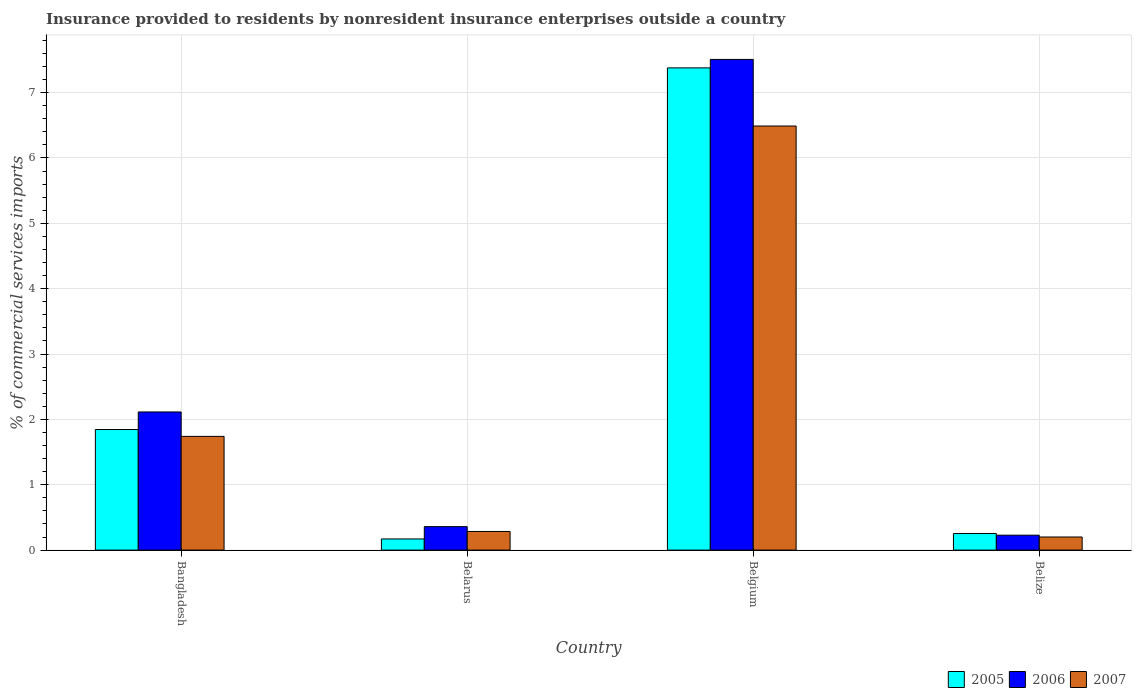How many different coloured bars are there?
Your answer should be very brief. 3. How many groups of bars are there?
Keep it short and to the point. 4. How many bars are there on the 3rd tick from the left?
Give a very brief answer. 3. How many bars are there on the 1st tick from the right?
Make the answer very short. 3. What is the Insurance provided to residents in 2007 in Belgium?
Give a very brief answer. 6.49. Across all countries, what is the maximum Insurance provided to residents in 2006?
Your response must be concise. 7.51. Across all countries, what is the minimum Insurance provided to residents in 2006?
Your answer should be compact. 0.23. In which country was the Insurance provided to residents in 2007 minimum?
Make the answer very short. Belize. What is the total Insurance provided to residents in 2005 in the graph?
Keep it short and to the point. 9.65. What is the difference between the Insurance provided to residents in 2005 in Bangladesh and that in Belarus?
Ensure brevity in your answer.  1.67. What is the difference between the Insurance provided to residents in 2006 in Belgium and the Insurance provided to residents in 2005 in Belarus?
Keep it short and to the point. 7.34. What is the average Insurance provided to residents in 2005 per country?
Keep it short and to the point. 2.41. What is the difference between the Insurance provided to residents of/in 2005 and Insurance provided to residents of/in 2007 in Belarus?
Provide a short and direct response. -0.11. In how many countries, is the Insurance provided to residents in 2006 greater than 0.4 %?
Offer a very short reply. 2. What is the ratio of the Insurance provided to residents in 2006 in Bangladesh to that in Belize?
Provide a short and direct response. 9.26. What is the difference between the highest and the second highest Insurance provided to residents in 2007?
Keep it short and to the point. -1.45. What is the difference between the highest and the lowest Insurance provided to residents in 2006?
Your answer should be compact. 7.28. In how many countries, is the Insurance provided to residents in 2007 greater than the average Insurance provided to residents in 2007 taken over all countries?
Provide a short and direct response. 1. What does the 2nd bar from the left in Belarus represents?
Provide a succinct answer. 2006. Is it the case that in every country, the sum of the Insurance provided to residents in 2005 and Insurance provided to residents in 2006 is greater than the Insurance provided to residents in 2007?
Give a very brief answer. Yes. How many bars are there?
Ensure brevity in your answer.  12. Are all the bars in the graph horizontal?
Keep it short and to the point. No. Are the values on the major ticks of Y-axis written in scientific E-notation?
Your answer should be compact. No. Does the graph contain grids?
Offer a very short reply. Yes. What is the title of the graph?
Your answer should be compact. Insurance provided to residents by nonresident insurance enterprises outside a country. What is the label or title of the Y-axis?
Your response must be concise. % of commercial services imports. What is the % of commercial services imports of 2005 in Bangladesh?
Your answer should be very brief. 1.85. What is the % of commercial services imports in 2006 in Bangladesh?
Your response must be concise. 2.11. What is the % of commercial services imports of 2007 in Bangladesh?
Your answer should be compact. 1.74. What is the % of commercial services imports in 2005 in Belarus?
Your answer should be very brief. 0.17. What is the % of commercial services imports in 2006 in Belarus?
Your answer should be very brief. 0.36. What is the % of commercial services imports in 2007 in Belarus?
Your answer should be compact. 0.29. What is the % of commercial services imports of 2005 in Belgium?
Provide a succinct answer. 7.38. What is the % of commercial services imports of 2006 in Belgium?
Offer a very short reply. 7.51. What is the % of commercial services imports in 2007 in Belgium?
Offer a very short reply. 6.49. What is the % of commercial services imports in 2005 in Belize?
Provide a short and direct response. 0.25. What is the % of commercial services imports in 2006 in Belize?
Your response must be concise. 0.23. What is the % of commercial services imports in 2007 in Belize?
Offer a terse response. 0.2. Across all countries, what is the maximum % of commercial services imports of 2005?
Make the answer very short. 7.38. Across all countries, what is the maximum % of commercial services imports in 2006?
Your answer should be compact. 7.51. Across all countries, what is the maximum % of commercial services imports of 2007?
Make the answer very short. 6.49. Across all countries, what is the minimum % of commercial services imports in 2005?
Keep it short and to the point. 0.17. Across all countries, what is the minimum % of commercial services imports in 2006?
Keep it short and to the point. 0.23. Across all countries, what is the minimum % of commercial services imports of 2007?
Your response must be concise. 0.2. What is the total % of commercial services imports of 2005 in the graph?
Keep it short and to the point. 9.65. What is the total % of commercial services imports of 2006 in the graph?
Your answer should be very brief. 10.21. What is the total % of commercial services imports of 2007 in the graph?
Keep it short and to the point. 8.71. What is the difference between the % of commercial services imports of 2005 in Bangladesh and that in Belarus?
Offer a very short reply. 1.67. What is the difference between the % of commercial services imports of 2006 in Bangladesh and that in Belarus?
Your response must be concise. 1.75. What is the difference between the % of commercial services imports of 2007 in Bangladesh and that in Belarus?
Provide a short and direct response. 1.45. What is the difference between the % of commercial services imports in 2005 in Bangladesh and that in Belgium?
Your answer should be very brief. -5.53. What is the difference between the % of commercial services imports of 2006 in Bangladesh and that in Belgium?
Your answer should be very brief. -5.39. What is the difference between the % of commercial services imports in 2007 in Bangladesh and that in Belgium?
Give a very brief answer. -4.75. What is the difference between the % of commercial services imports of 2005 in Bangladesh and that in Belize?
Provide a short and direct response. 1.59. What is the difference between the % of commercial services imports of 2006 in Bangladesh and that in Belize?
Make the answer very short. 1.89. What is the difference between the % of commercial services imports in 2007 in Bangladesh and that in Belize?
Provide a short and direct response. 1.54. What is the difference between the % of commercial services imports in 2005 in Belarus and that in Belgium?
Provide a short and direct response. -7.21. What is the difference between the % of commercial services imports in 2006 in Belarus and that in Belgium?
Provide a succinct answer. -7.15. What is the difference between the % of commercial services imports of 2007 in Belarus and that in Belgium?
Ensure brevity in your answer.  -6.2. What is the difference between the % of commercial services imports of 2005 in Belarus and that in Belize?
Offer a very short reply. -0.08. What is the difference between the % of commercial services imports of 2006 in Belarus and that in Belize?
Ensure brevity in your answer.  0.13. What is the difference between the % of commercial services imports in 2007 in Belarus and that in Belize?
Offer a terse response. 0.08. What is the difference between the % of commercial services imports in 2005 in Belgium and that in Belize?
Ensure brevity in your answer.  7.12. What is the difference between the % of commercial services imports of 2006 in Belgium and that in Belize?
Keep it short and to the point. 7.28. What is the difference between the % of commercial services imports of 2007 in Belgium and that in Belize?
Provide a succinct answer. 6.29. What is the difference between the % of commercial services imports of 2005 in Bangladesh and the % of commercial services imports of 2006 in Belarus?
Your answer should be very brief. 1.49. What is the difference between the % of commercial services imports of 2005 in Bangladesh and the % of commercial services imports of 2007 in Belarus?
Give a very brief answer. 1.56. What is the difference between the % of commercial services imports of 2006 in Bangladesh and the % of commercial services imports of 2007 in Belarus?
Offer a very short reply. 1.83. What is the difference between the % of commercial services imports of 2005 in Bangladesh and the % of commercial services imports of 2006 in Belgium?
Offer a very short reply. -5.66. What is the difference between the % of commercial services imports in 2005 in Bangladesh and the % of commercial services imports in 2007 in Belgium?
Provide a succinct answer. -4.64. What is the difference between the % of commercial services imports in 2006 in Bangladesh and the % of commercial services imports in 2007 in Belgium?
Make the answer very short. -4.38. What is the difference between the % of commercial services imports of 2005 in Bangladesh and the % of commercial services imports of 2006 in Belize?
Make the answer very short. 1.62. What is the difference between the % of commercial services imports of 2005 in Bangladesh and the % of commercial services imports of 2007 in Belize?
Your answer should be compact. 1.64. What is the difference between the % of commercial services imports of 2006 in Bangladesh and the % of commercial services imports of 2007 in Belize?
Ensure brevity in your answer.  1.91. What is the difference between the % of commercial services imports in 2005 in Belarus and the % of commercial services imports in 2006 in Belgium?
Your response must be concise. -7.34. What is the difference between the % of commercial services imports of 2005 in Belarus and the % of commercial services imports of 2007 in Belgium?
Your answer should be compact. -6.32. What is the difference between the % of commercial services imports of 2006 in Belarus and the % of commercial services imports of 2007 in Belgium?
Make the answer very short. -6.13. What is the difference between the % of commercial services imports in 2005 in Belarus and the % of commercial services imports in 2006 in Belize?
Make the answer very short. -0.06. What is the difference between the % of commercial services imports of 2005 in Belarus and the % of commercial services imports of 2007 in Belize?
Offer a terse response. -0.03. What is the difference between the % of commercial services imports of 2006 in Belarus and the % of commercial services imports of 2007 in Belize?
Offer a very short reply. 0.16. What is the difference between the % of commercial services imports in 2005 in Belgium and the % of commercial services imports in 2006 in Belize?
Ensure brevity in your answer.  7.15. What is the difference between the % of commercial services imports of 2005 in Belgium and the % of commercial services imports of 2007 in Belize?
Offer a terse response. 7.18. What is the difference between the % of commercial services imports of 2006 in Belgium and the % of commercial services imports of 2007 in Belize?
Your answer should be very brief. 7.31. What is the average % of commercial services imports in 2005 per country?
Make the answer very short. 2.41. What is the average % of commercial services imports of 2006 per country?
Make the answer very short. 2.55. What is the average % of commercial services imports of 2007 per country?
Make the answer very short. 2.18. What is the difference between the % of commercial services imports in 2005 and % of commercial services imports in 2006 in Bangladesh?
Provide a short and direct response. -0.27. What is the difference between the % of commercial services imports of 2005 and % of commercial services imports of 2007 in Bangladesh?
Ensure brevity in your answer.  0.11. What is the difference between the % of commercial services imports of 2006 and % of commercial services imports of 2007 in Bangladesh?
Make the answer very short. 0.37. What is the difference between the % of commercial services imports of 2005 and % of commercial services imports of 2006 in Belarus?
Keep it short and to the point. -0.19. What is the difference between the % of commercial services imports of 2005 and % of commercial services imports of 2007 in Belarus?
Your answer should be compact. -0.11. What is the difference between the % of commercial services imports in 2006 and % of commercial services imports in 2007 in Belarus?
Give a very brief answer. 0.07. What is the difference between the % of commercial services imports of 2005 and % of commercial services imports of 2006 in Belgium?
Your response must be concise. -0.13. What is the difference between the % of commercial services imports in 2005 and % of commercial services imports in 2007 in Belgium?
Provide a short and direct response. 0.89. What is the difference between the % of commercial services imports of 2006 and % of commercial services imports of 2007 in Belgium?
Your answer should be very brief. 1.02. What is the difference between the % of commercial services imports in 2005 and % of commercial services imports in 2006 in Belize?
Offer a terse response. 0.03. What is the difference between the % of commercial services imports of 2005 and % of commercial services imports of 2007 in Belize?
Give a very brief answer. 0.05. What is the difference between the % of commercial services imports in 2006 and % of commercial services imports in 2007 in Belize?
Your answer should be compact. 0.03. What is the ratio of the % of commercial services imports of 2005 in Bangladesh to that in Belarus?
Make the answer very short. 10.81. What is the ratio of the % of commercial services imports in 2006 in Bangladesh to that in Belarus?
Make the answer very short. 5.89. What is the ratio of the % of commercial services imports of 2007 in Bangladesh to that in Belarus?
Your answer should be compact. 6.1. What is the ratio of the % of commercial services imports of 2005 in Bangladesh to that in Belgium?
Your answer should be compact. 0.25. What is the ratio of the % of commercial services imports in 2006 in Bangladesh to that in Belgium?
Your response must be concise. 0.28. What is the ratio of the % of commercial services imports in 2007 in Bangladesh to that in Belgium?
Keep it short and to the point. 0.27. What is the ratio of the % of commercial services imports of 2005 in Bangladesh to that in Belize?
Make the answer very short. 7.27. What is the ratio of the % of commercial services imports of 2006 in Bangladesh to that in Belize?
Offer a terse response. 9.26. What is the ratio of the % of commercial services imports in 2007 in Bangladesh to that in Belize?
Offer a terse response. 8.68. What is the ratio of the % of commercial services imports of 2005 in Belarus to that in Belgium?
Keep it short and to the point. 0.02. What is the ratio of the % of commercial services imports of 2006 in Belarus to that in Belgium?
Provide a succinct answer. 0.05. What is the ratio of the % of commercial services imports in 2007 in Belarus to that in Belgium?
Your answer should be compact. 0.04. What is the ratio of the % of commercial services imports of 2005 in Belarus to that in Belize?
Your response must be concise. 0.67. What is the ratio of the % of commercial services imports in 2006 in Belarus to that in Belize?
Your answer should be compact. 1.57. What is the ratio of the % of commercial services imports in 2007 in Belarus to that in Belize?
Offer a very short reply. 1.42. What is the ratio of the % of commercial services imports of 2005 in Belgium to that in Belize?
Your response must be concise. 29.09. What is the ratio of the % of commercial services imports in 2006 in Belgium to that in Belize?
Offer a terse response. 32.89. What is the ratio of the % of commercial services imports in 2007 in Belgium to that in Belize?
Provide a succinct answer. 32.36. What is the difference between the highest and the second highest % of commercial services imports in 2005?
Provide a succinct answer. 5.53. What is the difference between the highest and the second highest % of commercial services imports of 2006?
Keep it short and to the point. 5.39. What is the difference between the highest and the second highest % of commercial services imports in 2007?
Your response must be concise. 4.75. What is the difference between the highest and the lowest % of commercial services imports of 2005?
Your answer should be compact. 7.21. What is the difference between the highest and the lowest % of commercial services imports of 2006?
Provide a short and direct response. 7.28. What is the difference between the highest and the lowest % of commercial services imports of 2007?
Offer a very short reply. 6.29. 